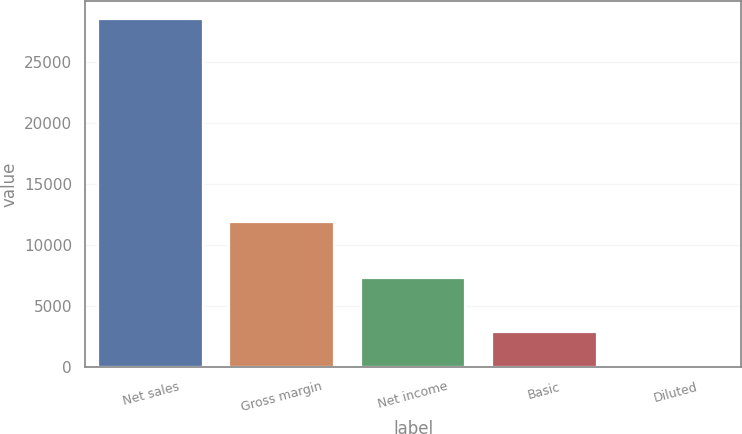Convert chart. <chart><loc_0><loc_0><loc_500><loc_500><bar_chart><fcel>Net sales<fcel>Gross margin<fcel>Net income<fcel>Basic<fcel>Diluted<nl><fcel>28571<fcel>11922<fcel>7308<fcel>2864.11<fcel>7.79<nl></chart> 